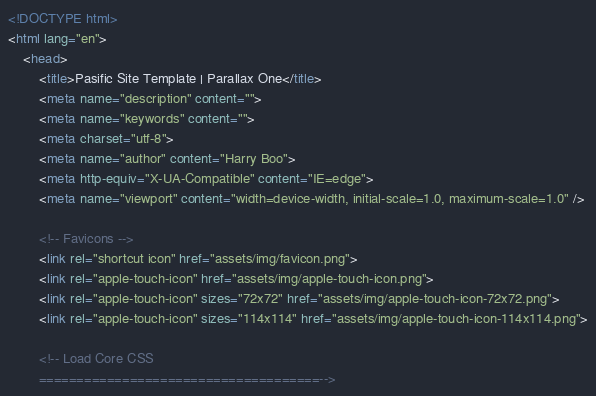Convert code to text. <code><loc_0><loc_0><loc_500><loc_500><_HTML_><!DOCTYPE html>
<html lang="en">
    <head>
        <title>Pasific Site Template | Parallax One</title>
        <meta name="description" content="">
        <meta name="keywords" content="">
        <meta charset="utf-8">
        <meta name="author" content="Harry Boo">
        <meta http-equiv="X-UA-Compatible" content="IE=edge">
        <meta name="viewport" content="width=device-width, initial-scale=1.0, maximum-scale=1.0" />
        
        <!-- Favicons -->
        <link rel="shortcut icon" href="assets/img/favicon.png">
        <link rel="apple-touch-icon" href="assets/img/apple-touch-icon.png">
        <link rel="apple-touch-icon" sizes="72x72" href="assets/img/apple-touch-icon-72x72.png">
        <link rel="apple-touch-icon" sizes="114x114" href="assets/img/apple-touch-icon-114x114.png">
        
        <!-- Load Core CSS 
        =====================================--></code> 